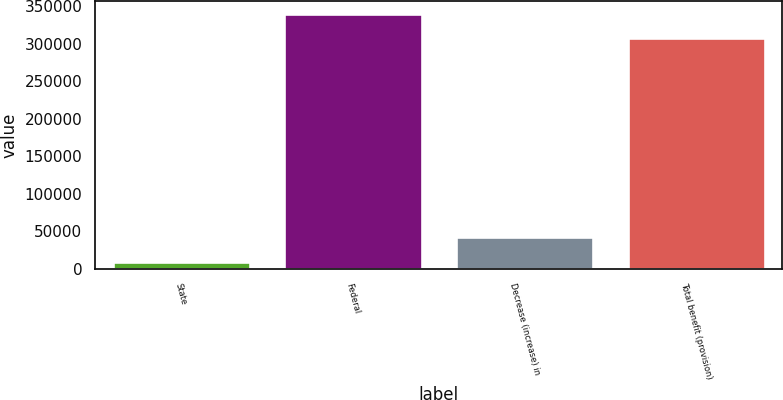Convert chart to OTSL. <chart><loc_0><loc_0><loc_500><loc_500><bar_chart><fcel>State<fcel>Federal<fcel>Decrease (increase) in<fcel>Total benefit (provision)<nl><fcel>9689<fcel>339820<fcel>42479.6<fcel>307029<nl></chart> 